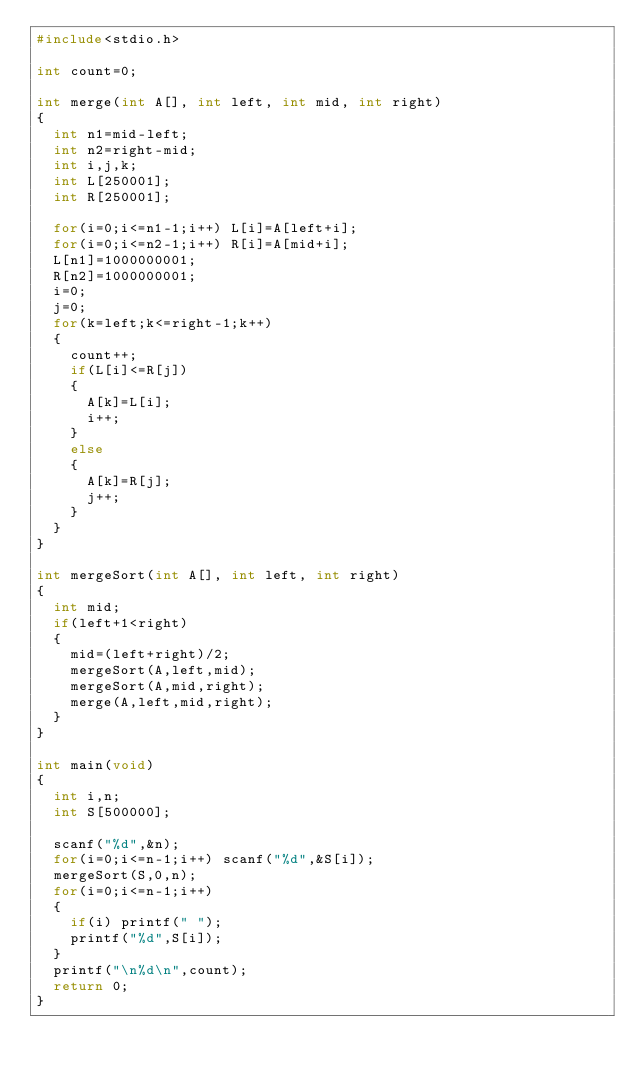Convert code to text. <code><loc_0><loc_0><loc_500><loc_500><_C_>#include<stdio.h>

int count=0;

int merge(int A[], int left, int mid, int right)
{
	int n1=mid-left;
	int n2=right-mid;
	int i,j,k;
	int L[250001];
	int R[250001];
	
	for(i=0;i<=n1-1;i++) L[i]=A[left+i];
	for(i=0;i<=n2-1;i++) R[i]=A[mid+i];
	L[n1]=1000000001;
	R[n2]=1000000001;
	i=0;
	j=0;
	for(k=left;k<=right-1;k++)
	{
		count++;
		if(L[i]<=R[j])
		{
			A[k]=L[i];
			i++;
		}
		else
		{
			A[k]=R[j];
			j++;
		}
	}
}

int mergeSort(int A[], int left, int right)
{
	int mid;
	if(left+1<right)
	{
		mid=(left+right)/2;
		mergeSort(A,left,mid);
		mergeSort(A,mid,right);
		merge(A,left,mid,right);
	}
}

int main(void)
{
	int i,n;
	int S[500000];
	
	scanf("%d",&n);
	for(i=0;i<=n-1;i++) scanf("%d",&S[i]);
	mergeSort(S,0,n);
	for(i=0;i<=n-1;i++)
	{
		if(i) printf(" ");
		printf("%d",S[i]);
	}
	printf("\n%d\n",count);
	return 0;
}</code> 